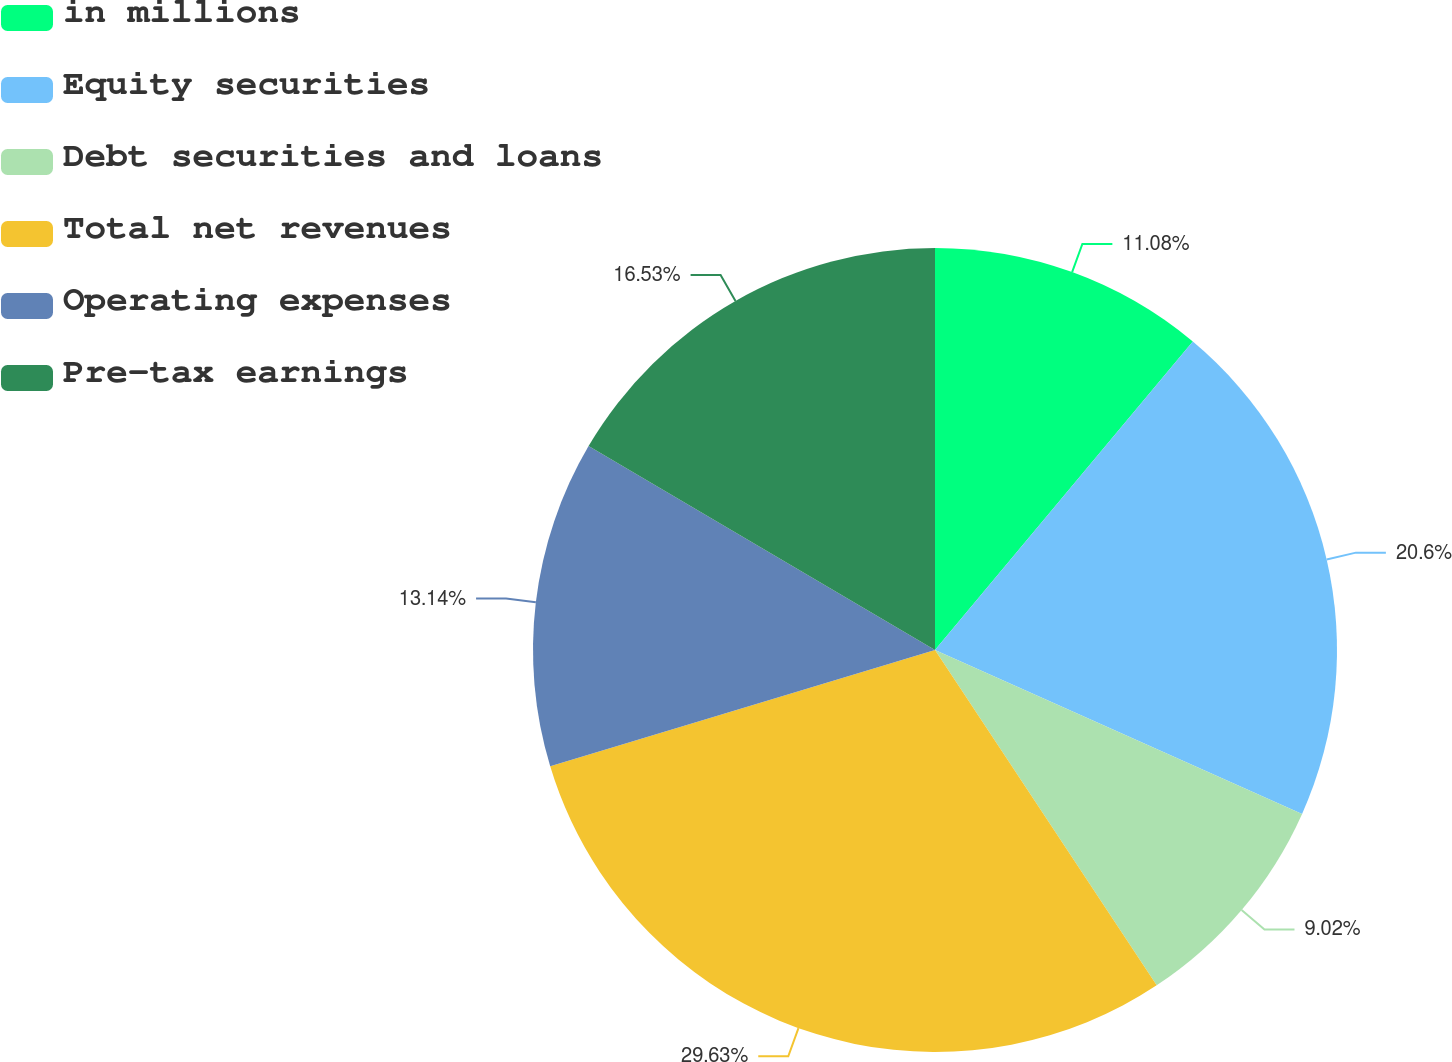Convert chart. <chart><loc_0><loc_0><loc_500><loc_500><pie_chart><fcel>in millions<fcel>Equity securities<fcel>Debt securities and loans<fcel>Total net revenues<fcel>Operating expenses<fcel>Pre-tax earnings<nl><fcel>11.08%<fcel>20.6%<fcel>9.02%<fcel>29.62%<fcel>13.14%<fcel>16.53%<nl></chart> 